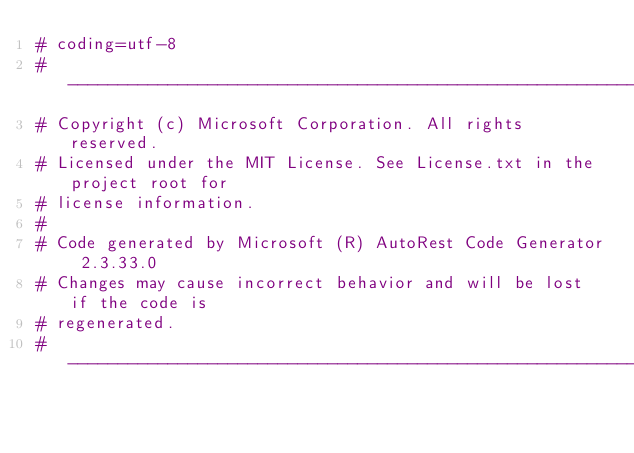Convert code to text. <code><loc_0><loc_0><loc_500><loc_500><_Python_># coding=utf-8
# --------------------------------------------------------------------------
# Copyright (c) Microsoft Corporation. All rights reserved.
# Licensed under the MIT License. See License.txt in the project root for
# license information.
#
# Code generated by Microsoft (R) AutoRest Code Generator 2.3.33.0
# Changes may cause incorrect behavior and will be lost if the code is
# regenerated.
# --------------------------------------------------------------------------
</code> 